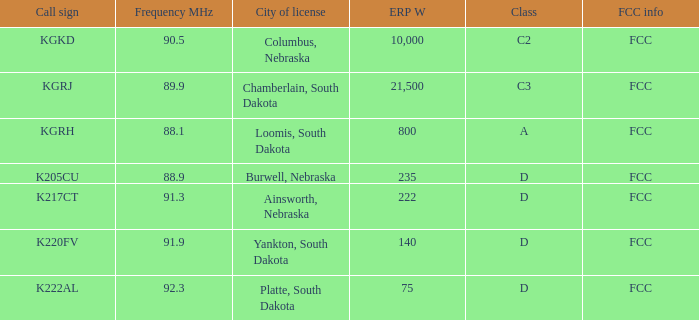For the kgrj call sign having an erp w over 21,500, what is the overall frequency in mhz? 0.0. 